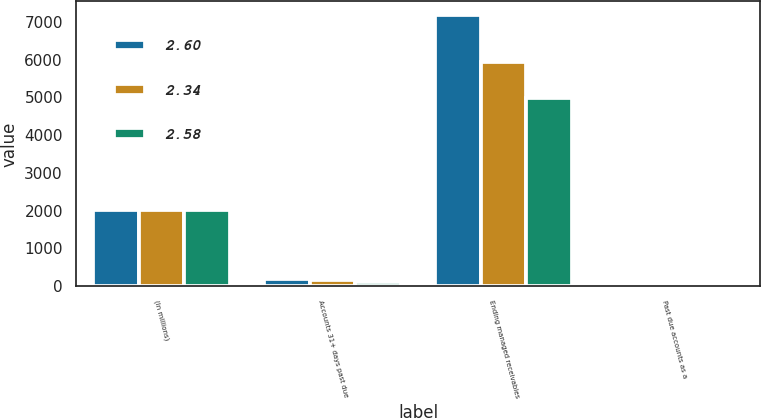Convert chart to OTSL. <chart><loc_0><loc_0><loc_500><loc_500><stacked_bar_chart><ecel><fcel>(In millions)<fcel>Accounts 31+ days past due<fcel>Ending managed receivables<fcel>Past due accounts as a<nl><fcel>2.6<fcel>2014<fcel>185.2<fcel>7184.4<fcel>2.58<nl><fcel>2.34<fcel>2013<fcel>154.2<fcel>5933.3<fcel>2.6<nl><fcel>2.58<fcel>2012<fcel>116.5<fcel>4981.8<fcel>2.34<nl></chart> 